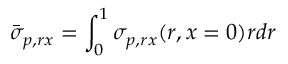Convert formula to latex. <formula><loc_0><loc_0><loc_500><loc_500>\bar { \sigma } _ { p , r x } = \int _ { 0 } ^ { 1 } \sigma _ { p , r x } ( r , x = 0 ) r d r</formula> 